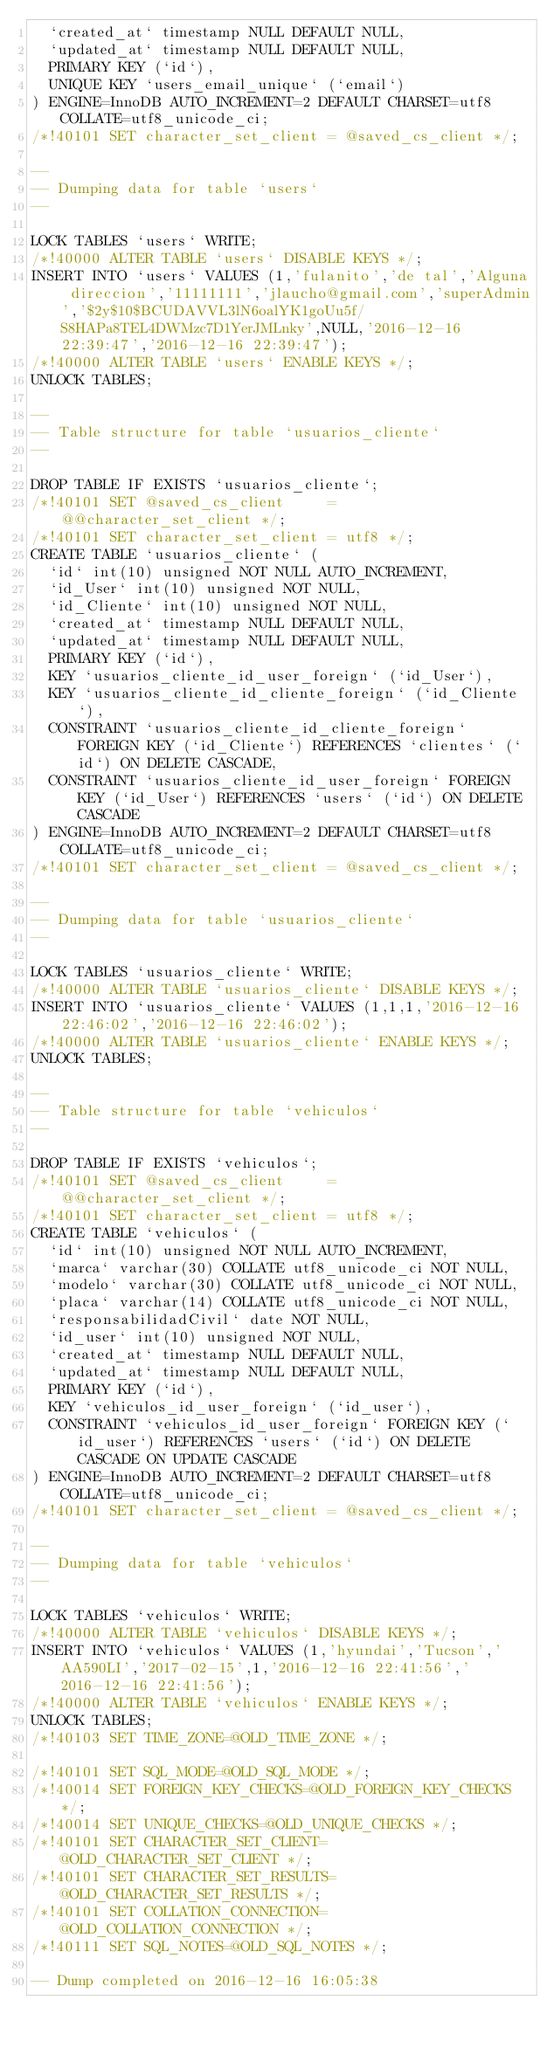Convert code to text. <code><loc_0><loc_0><loc_500><loc_500><_SQL_>  `created_at` timestamp NULL DEFAULT NULL,
  `updated_at` timestamp NULL DEFAULT NULL,
  PRIMARY KEY (`id`),
  UNIQUE KEY `users_email_unique` (`email`)
) ENGINE=InnoDB AUTO_INCREMENT=2 DEFAULT CHARSET=utf8 COLLATE=utf8_unicode_ci;
/*!40101 SET character_set_client = @saved_cs_client */;

--
-- Dumping data for table `users`
--

LOCK TABLES `users` WRITE;
/*!40000 ALTER TABLE `users` DISABLE KEYS */;
INSERT INTO `users` VALUES (1,'fulanito','de tal','Alguna direccion','11111111','jlaucho@gmail.com','superAdmin','$2y$10$BCUDAVVL3lN6oalYK1goUu5f/S8HAPa8TEL4DWMzc7D1YerJMLnky',NULL,'2016-12-16 22:39:47','2016-12-16 22:39:47');
/*!40000 ALTER TABLE `users` ENABLE KEYS */;
UNLOCK TABLES;

--
-- Table structure for table `usuarios_cliente`
--

DROP TABLE IF EXISTS `usuarios_cliente`;
/*!40101 SET @saved_cs_client     = @@character_set_client */;
/*!40101 SET character_set_client = utf8 */;
CREATE TABLE `usuarios_cliente` (
  `id` int(10) unsigned NOT NULL AUTO_INCREMENT,
  `id_User` int(10) unsigned NOT NULL,
  `id_Cliente` int(10) unsigned NOT NULL,
  `created_at` timestamp NULL DEFAULT NULL,
  `updated_at` timestamp NULL DEFAULT NULL,
  PRIMARY KEY (`id`),
  KEY `usuarios_cliente_id_user_foreign` (`id_User`),
  KEY `usuarios_cliente_id_cliente_foreign` (`id_Cliente`),
  CONSTRAINT `usuarios_cliente_id_cliente_foreign` FOREIGN KEY (`id_Cliente`) REFERENCES `clientes` (`id`) ON DELETE CASCADE,
  CONSTRAINT `usuarios_cliente_id_user_foreign` FOREIGN KEY (`id_User`) REFERENCES `users` (`id`) ON DELETE CASCADE
) ENGINE=InnoDB AUTO_INCREMENT=2 DEFAULT CHARSET=utf8 COLLATE=utf8_unicode_ci;
/*!40101 SET character_set_client = @saved_cs_client */;

--
-- Dumping data for table `usuarios_cliente`
--

LOCK TABLES `usuarios_cliente` WRITE;
/*!40000 ALTER TABLE `usuarios_cliente` DISABLE KEYS */;
INSERT INTO `usuarios_cliente` VALUES (1,1,1,'2016-12-16 22:46:02','2016-12-16 22:46:02');
/*!40000 ALTER TABLE `usuarios_cliente` ENABLE KEYS */;
UNLOCK TABLES;

--
-- Table structure for table `vehiculos`
--

DROP TABLE IF EXISTS `vehiculos`;
/*!40101 SET @saved_cs_client     = @@character_set_client */;
/*!40101 SET character_set_client = utf8 */;
CREATE TABLE `vehiculos` (
  `id` int(10) unsigned NOT NULL AUTO_INCREMENT,
  `marca` varchar(30) COLLATE utf8_unicode_ci NOT NULL,
  `modelo` varchar(30) COLLATE utf8_unicode_ci NOT NULL,
  `placa` varchar(14) COLLATE utf8_unicode_ci NOT NULL,
  `responsabilidadCivil` date NOT NULL,
  `id_user` int(10) unsigned NOT NULL,
  `created_at` timestamp NULL DEFAULT NULL,
  `updated_at` timestamp NULL DEFAULT NULL,
  PRIMARY KEY (`id`),
  KEY `vehiculos_id_user_foreign` (`id_user`),
  CONSTRAINT `vehiculos_id_user_foreign` FOREIGN KEY (`id_user`) REFERENCES `users` (`id`) ON DELETE CASCADE ON UPDATE CASCADE
) ENGINE=InnoDB AUTO_INCREMENT=2 DEFAULT CHARSET=utf8 COLLATE=utf8_unicode_ci;
/*!40101 SET character_set_client = @saved_cs_client */;

--
-- Dumping data for table `vehiculos`
--

LOCK TABLES `vehiculos` WRITE;
/*!40000 ALTER TABLE `vehiculos` DISABLE KEYS */;
INSERT INTO `vehiculos` VALUES (1,'hyundai','Tucson','AA590LI','2017-02-15',1,'2016-12-16 22:41:56','2016-12-16 22:41:56');
/*!40000 ALTER TABLE `vehiculos` ENABLE KEYS */;
UNLOCK TABLES;
/*!40103 SET TIME_ZONE=@OLD_TIME_ZONE */;

/*!40101 SET SQL_MODE=@OLD_SQL_MODE */;
/*!40014 SET FOREIGN_KEY_CHECKS=@OLD_FOREIGN_KEY_CHECKS */;
/*!40014 SET UNIQUE_CHECKS=@OLD_UNIQUE_CHECKS */;
/*!40101 SET CHARACTER_SET_CLIENT=@OLD_CHARACTER_SET_CLIENT */;
/*!40101 SET CHARACTER_SET_RESULTS=@OLD_CHARACTER_SET_RESULTS */;
/*!40101 SET COLLATION_CONNECTION=@OLD_COLLATION_CONNECTION */;
/*!40111 SET SQL_NOTES=@OLD_SQL_NOTES */;

-- Dump completed on 2016-12-16 16:05:38
</code> 